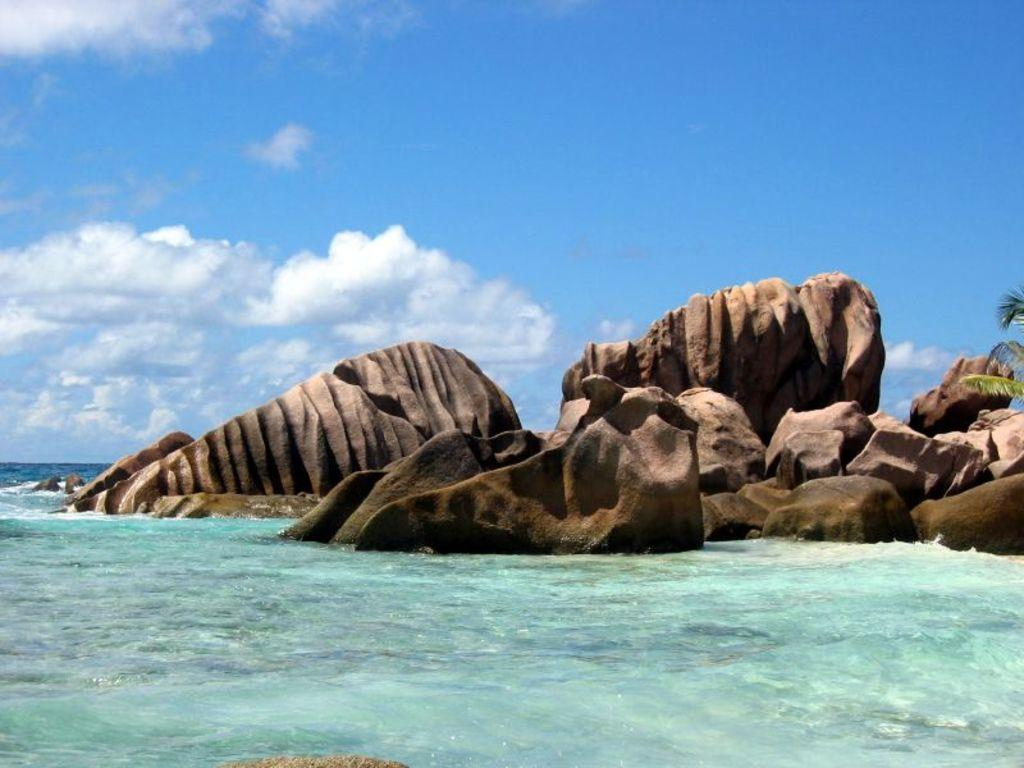What is at the bottom of the image? There is water at the bottom of the image. What can be seen on the right side of the image? There is a tree on the right side of the image. What type of natural features are visible in the background of the image? There are rocks in the background of the image. What is visible in the sky in the background of the image? The sky is visible in the background of the image. How does the tree help with the dog's debt in the image? There is no dog or debt mentioned in the image; it features water, a tree, rocks, and the sky. What type of adjustment can be seen in the image? There is no adjustment visible in the image; it shows a tree, water, rocks, and the sky. 